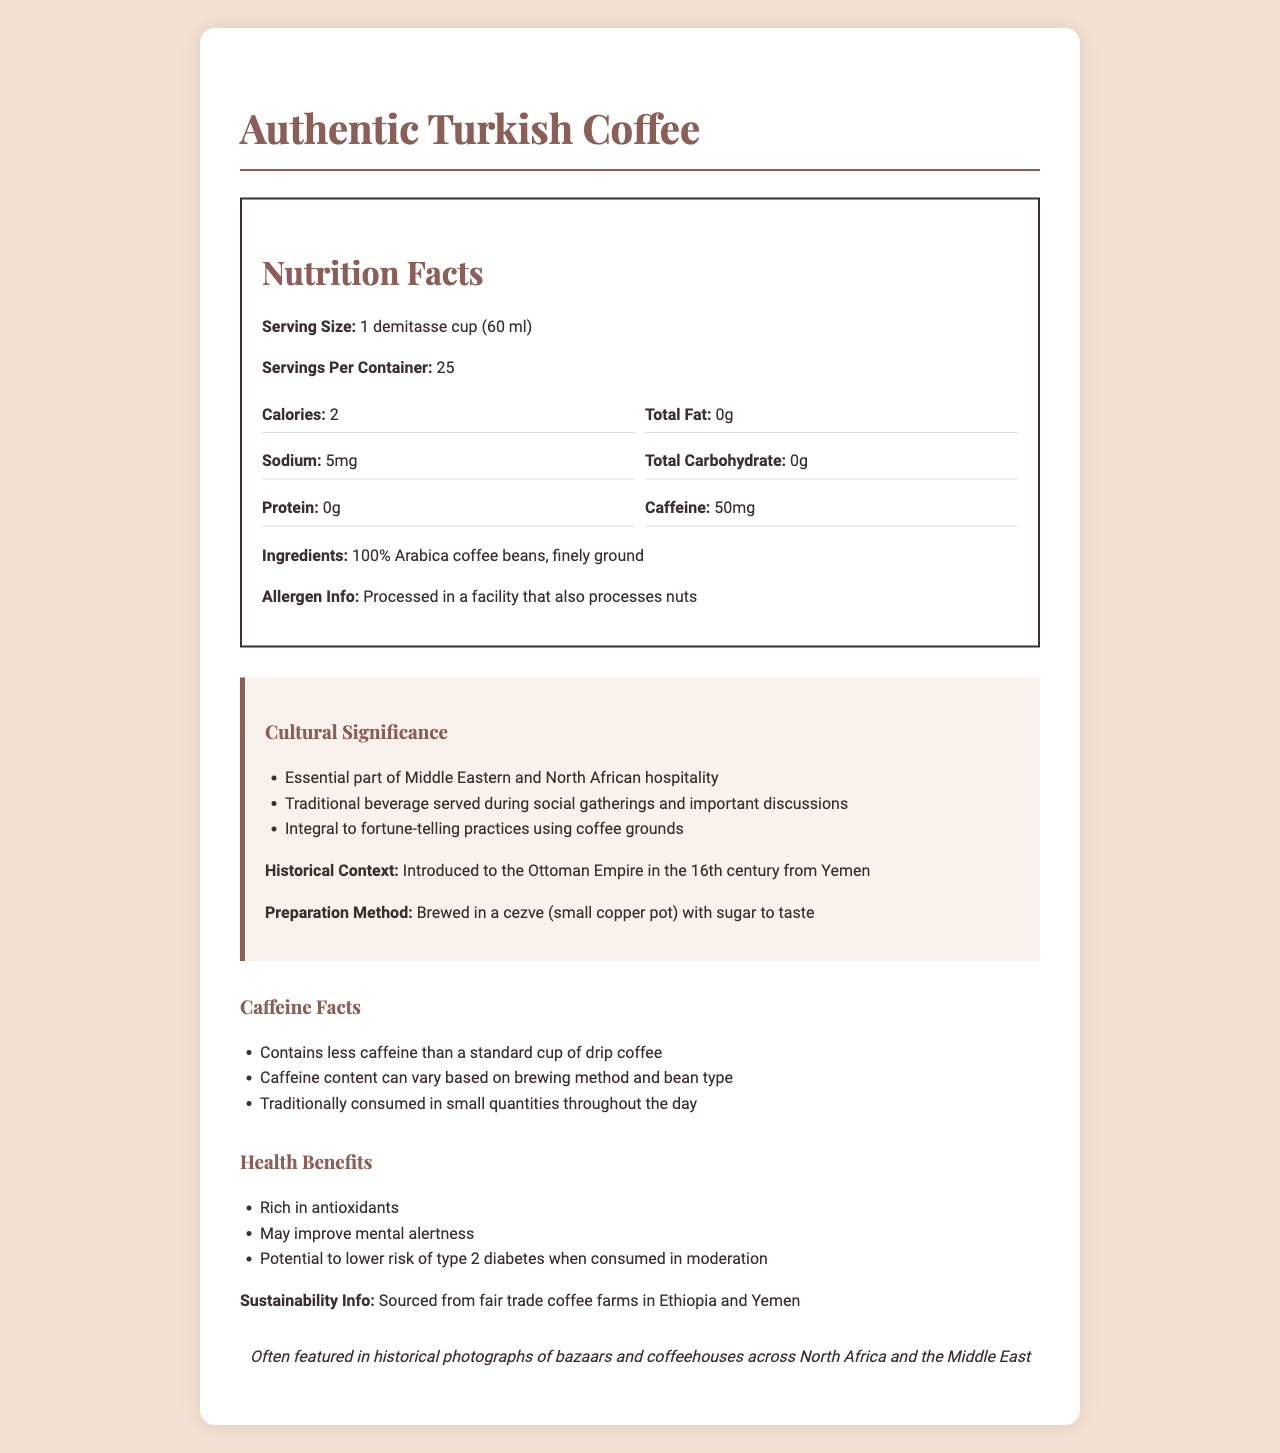what is the serving size for Authentic Turkish Coffee? The serving size is indicated in the "Nutrition Facts" section of the document.
Answer: 1 demitasse cup (60 ml) what is the caffeine content per serving? The document specifies that each serving contains 50 mg of caffeine.
Answer: 50 mg what is one of the regional variations of Turkish coffee? The document mentions several regional variations, one of which is Egyptian, often flavored with cardamom.
Answer: Egyptian: often flavored with cardamom how many calories are there per serving? The Nutrition Facts section lists the calories per serving as 2.
Answer: 2 calories what is the cultural significance of Turkish coffee in the Middle East? The document explains that Turkish coffee is an essential part of Middle Eastern and North African hospitality.
Answer: Essential part of Middle Eastern and North African hospitality what ingredients are used in Authentic Turkish Coffee? The ingredients listed in the document are 100% Arabica coffee beans, finely ground.
Answer: 100% Arabica coffee beans, finely ground what allergen information does the document provide? The allergen information notes that the product is processed in a facility that also processes nuts.
Answer: Processed in a facility that also processes nuts what is the historical context for Turkish coffee? The document states that Turkish coffee was introduced to the Ottoman Empire in the 16th century from Yemen.
Answer: Introduced to the Ottoman Empire in the 16th century from Yemen where are the coffee beans sourced from? The sustainability info mentions that the coffee beans are sourced from fair trade coffee farms in Ethiopia and Yemen.
Answer: Fair trade coffee farms in Ethiopia and Yemen how is Turkish coffee traditionally brewed? The preparation method section outlines that Turkish coffee is traditionally brewed in a cezve with sugar to taste.
Answer: Brewed in a cezve (small copper pot) with sugar to taste which of the following is NOT a regional variation mentioned in the document? A. Egyptian B. Lebanese C. Moroccan D. Algerian The document mentions Egyptian, Lebanese, and Algerian as regional variations, but not Moroccan.
Answer: C. Moroccan which item is commonly served with Turkish coffee? A. Turkish Delight B. Chocolate C. Croissant D. Fruit Salad The serving suggestions mention that Turkish coffee is often served with Turkish delight.
Answer: A. Turkish Delight does Turkish coffee contain more caffeine than a standard cup of drip coffee? According to the document, Turkish coffee contains less caffeine than a standard cup of drip coffee.
Answer: No summarize the main ideas of the document about Turkish Coffee. The document provides information on the nutritional content, cultural importance, preparation method, and historical context of Authentic Turkish Coffee. It details its moderate caffeine content, health benefits, and cultural practices surrounding its consumption, including various regional preparations. The document also mentions the origin of the coffee beans and sustainability practices.
Answer: Authentic Turkish Coffee is not only valued for its unique taste and moderate caffeine content but also holds cultural significance in Middle Eastern and North African hospitality. The coffee is traditionally brewed in a small copper pot (cezve) and served in social gatherings. It contains minimal calories and is rich in antioxidants, with health benefits like improved mental alertness. Additionally, the document highlights different regional variations and underscores its historical context as well as its sustainability efforts. how is the caffeine content affected by the brewing method and bean type? The document states that caffeine content can vary based on brewing method and bean type but does not provide specific details on how they affect the caffeine content.
Answer: Not enough information 